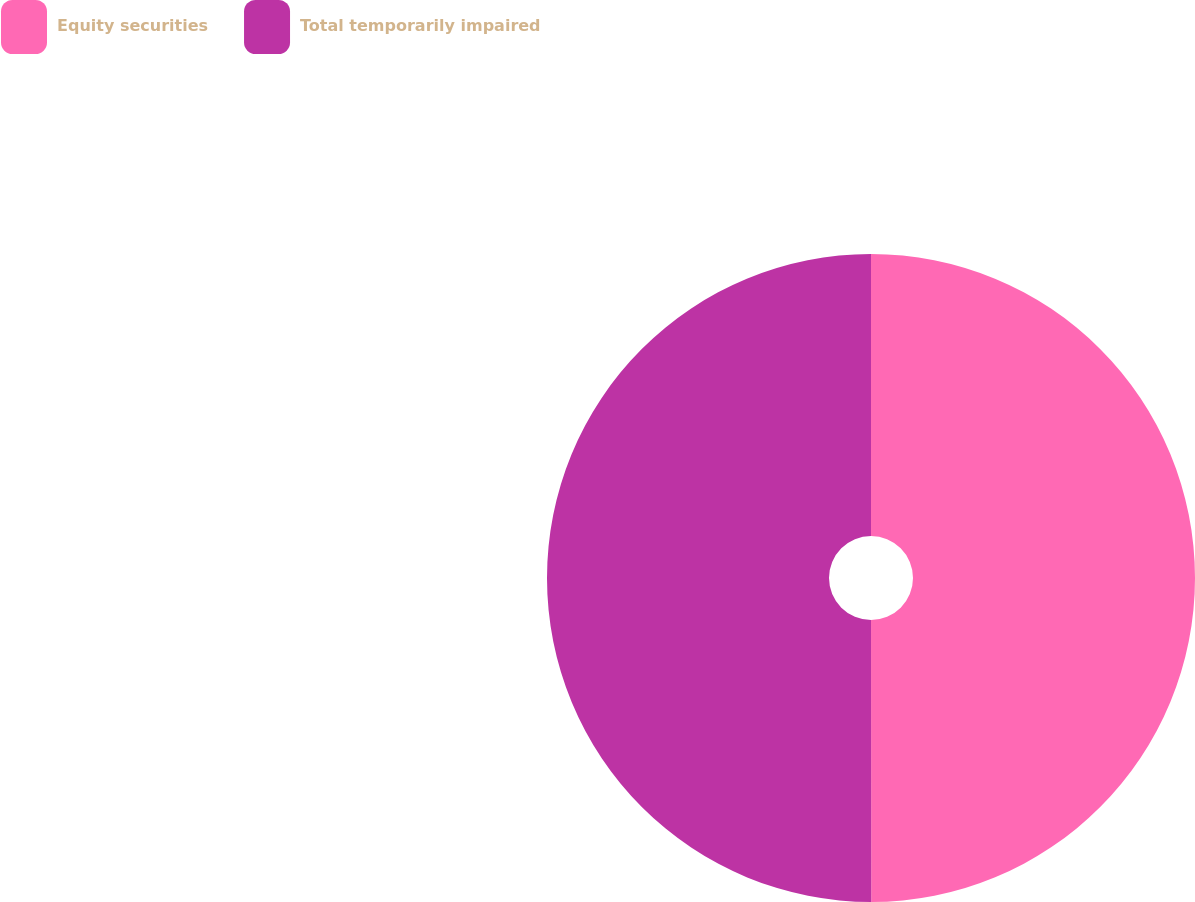<chart> <loc_0><loc_0><loc_500><loc_500><pie_chart><fcel>Equity securities<fcel>Total temporarily impaired<nl><fcel>49.99%<fcel>50.01%<nl></chart> 